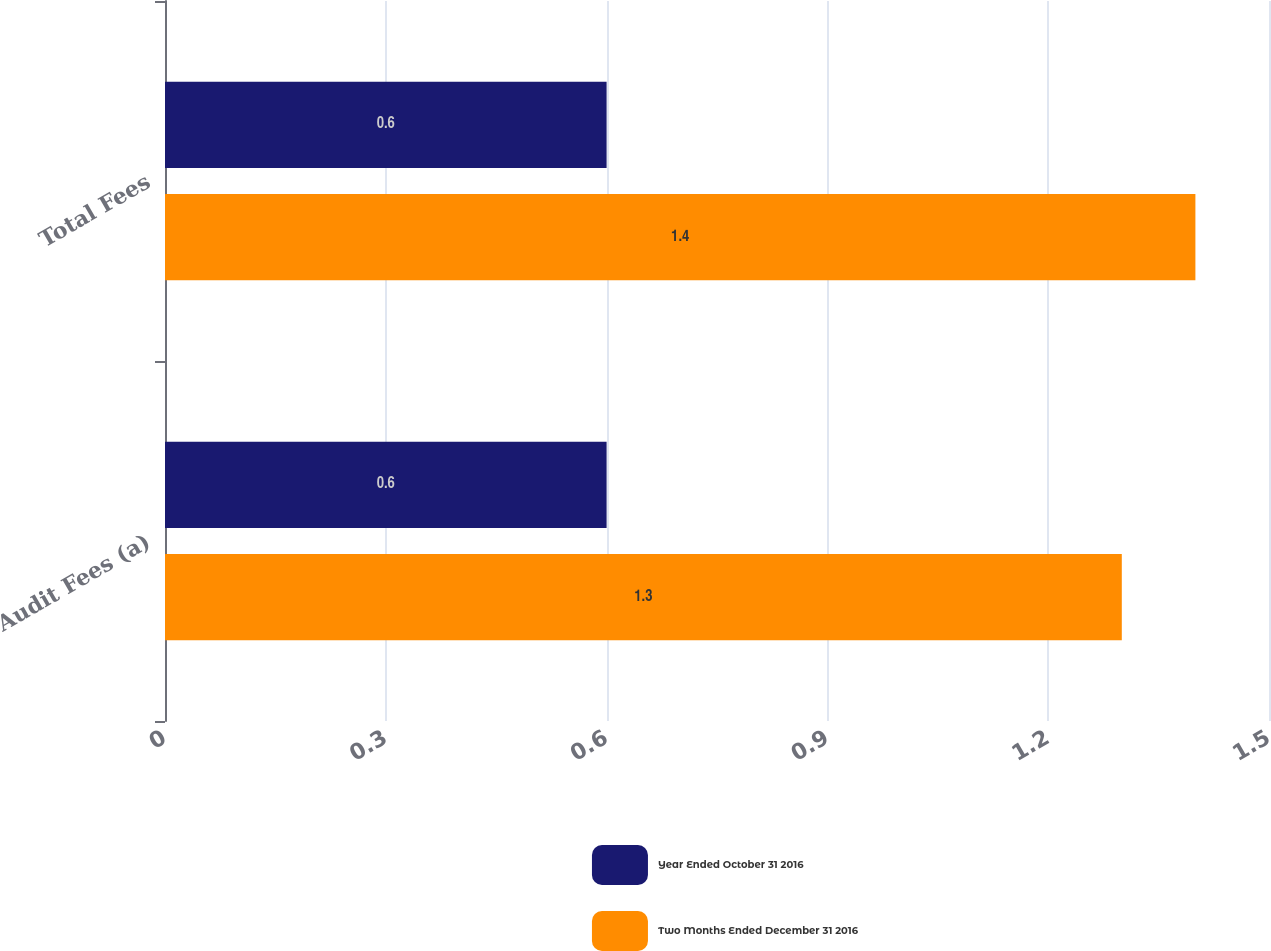Convert chart to OTSL. <chart><loc_0><loc_0><loc_500><loc_500><stacked_bar_chart><ecel><fcel>Audit Fees (a)<fcel>Total Fees<nl><fcel>Year Ended October 31 2016<fcel>0.6<fcel>0.6<nl><fcel>Two Months Ended December 31 2016<fcel>1.3<fcel>1.4<nl></chart> 